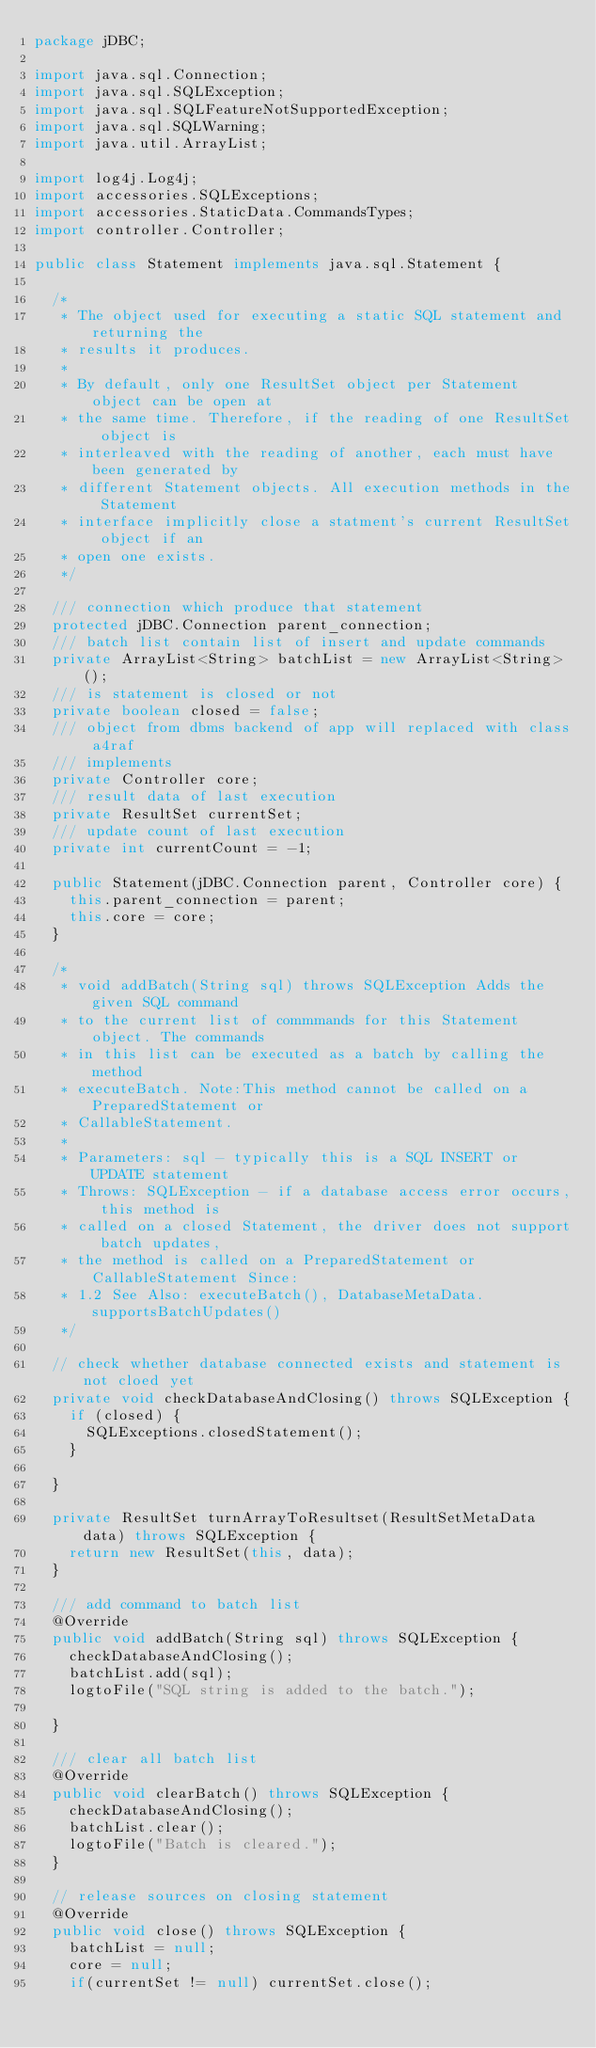Convert code to text. <code><loc_0><loc_0><loc_500><loc_500><_Java_>package jDBC;

import java.sql.Connection;
import java.sql.SQLException;
import java.sql.SQLFeatureNotSupportedException;
import java.sql.SQLWarning;
import java.util.ArrayList;

import log4j.Log4j;
import accessories.SQLExceptions;
import accessories.StaticData.CommandsTypes;
import controller.Controller;

public class Statement implements java.sql.Statement {

	/*
	 * The object used for executing a static SQL statement and returning the
	 * results it produces.
	 * 
	 * By default, only one ResultSet object per Statement object can be open at
	 * the same time. Therefore, if the reading of one ResultSet object is
	 * interleaved with the reading of another, each must have been generated by
	 * different Statement objects. All execution methods in the Statement
	 * interface implicitly close a statment's current ResultSet object if an
	 * open one exists.
	 */

	/// connection which produce that statement
	protected jDBC.Connection parent_connection;
	/// batch list contain list of insert and update commands
	private ArrayList<String> batchList = new ArrayList<String> ();
	/// is statement is closed or not
	private boolean closed = false;
	/// object from dbms backend of app will replaced with class a4raf
	/// implements
	private Controller core;
	/// result data of last execution
	private ResultSet currentSet;
	/// update count of last execution
	private int currentCount = -1;

	public Statement(jDBC.Connection parent, Controller core) {
		this.parent_connection = parent;
		this.core = core;
	}

	/*
	 * void addBatch(String sql) throws SQLException Adds the given SQL command
	 * to the current list of commmands for this Statement object. The commands
	 * in this list can be executed as a batch by calling the method
	 * executeBatch. Note:This method cannot be called on a PreparedStatement or
	 * CallableStatement.
	 * 
	 * Parameters: sql - typically this is a SQL INSERT or UPDATE statement
	 * Throws: SQLException - if a database access error occurs, this method is
	 * called on a closed Statement, the driver does not support batch updates,
	 * the method is called on a PreparedStatement or CallableStatement Since:
	 * 1.2 See Also: executeBatch(), DatabaseMetaData.supportsBatchUpdates()
	 */

	// check whether database connected exists and statement is not cloed yet
	private void checkDatabaseAndClosing() throws SQLException {
		if (closed) {
			SQLExceptions.closedStatement();
		}

	}

	private ResultSet turnArrayToResultset(ResultSetMetaData data) throws SQLException {
		return new ResultSet(this, data);
	}

	/// add command to batch list
	@Override
	public void addBatch(String sql) throws SQLException {
		checkDatabaseAndClosing();
		batchList.add(sql);
		logtoFile("SQL string is added to the batch.");
		
	}

	/// clear all batch list
	@Override
	public void clearBatch() throws SQLException {
		checkDatabaseAndClosing();
		batchList.clear();
		logtoFile("Batch is cleared.");
	}

	// release sources on closing statement
	@Override
	public void close() throws SQLException {
		batchList = null;
		core = null;
		if(currentSet != null) currentSet.close();</code> 